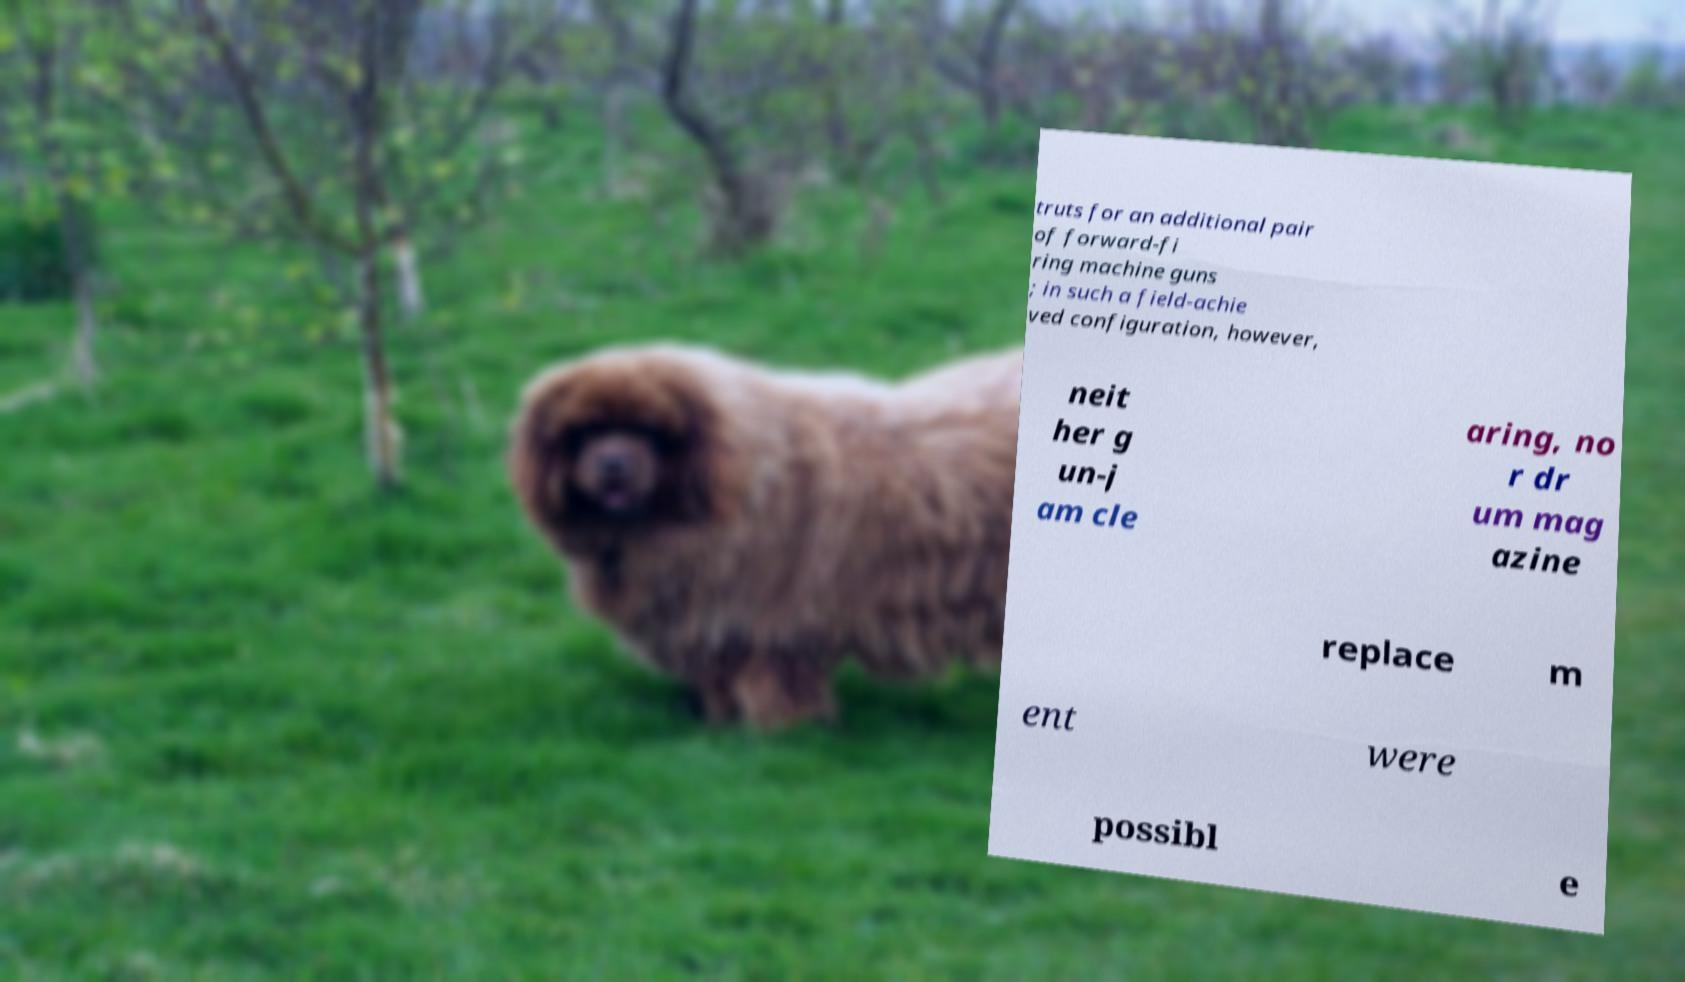Could you assist in decoding the text presented in this image and type it out clearly? truts for an additional pair of forward-fi ring machine guns ; in such a field-achie ved configuration, however, neit her g un-j am cle aring, no r dr um mag azine replace m ent were possibl e 